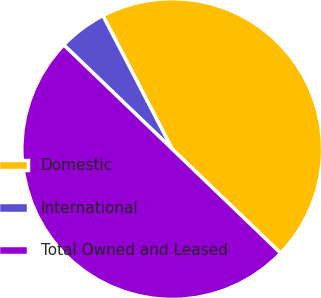Convert chart. <chart><loc_0><loc_0><loc_500><loc_500><pie_chart><fcel>Domestic<fcel>International<fcel>Total Owned and Leased<nl><fcel>44.8%<fcel>5.2%<fcel>50.0%<nl></chart> 